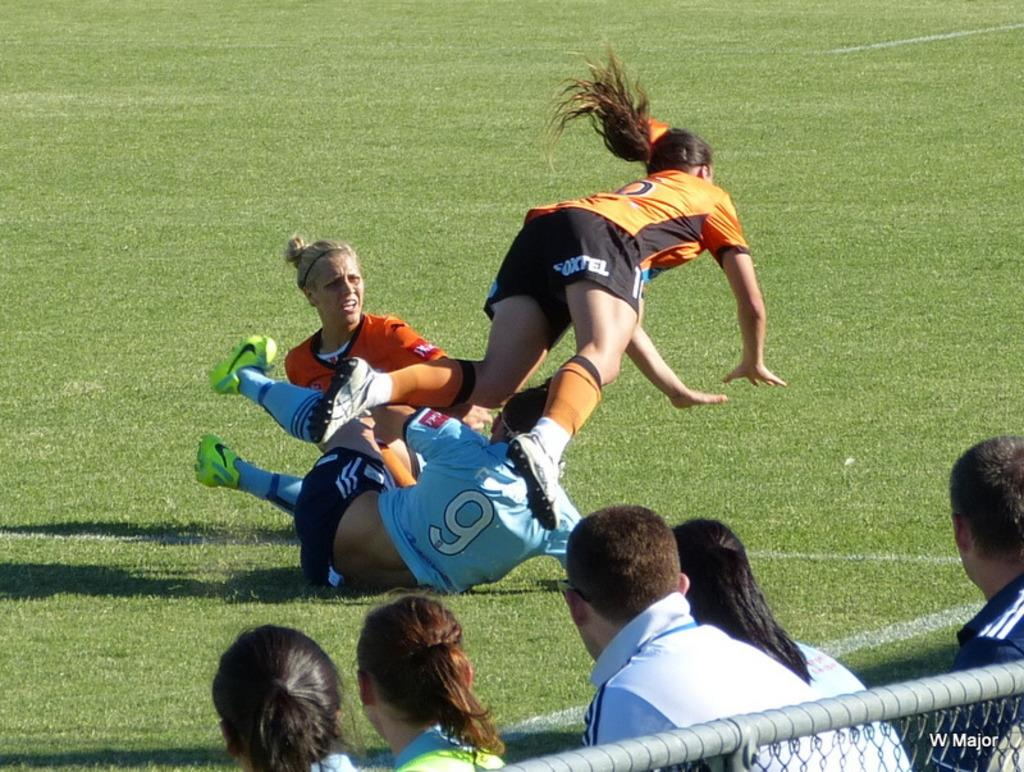Who or what can be seen in the image? There are people in the image. What are some of the people doing in the image? Some of the people are playing in the ground. What type of barrier is present in the image? There is a metal rod with fence in the image. What type of grass is being used to generate power in the image? There is no grass or power generation present in the image. 